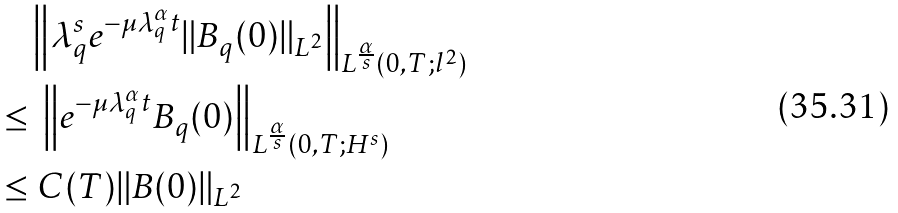Convert formula to latex. <formula><loc_0><loc_0><loc_500><loc_500>& \left \| \lambda _ { q } ^ { s } e ^ { - \mu \lambda _ { q } ^ { \alpha } t } \| B _ { q } ( 0 ) \| _ { L ^ { 2 } } \right \| _ { L ^ { \frac { \alpha } { s } } ( 0 , T ; l ^ { 2 } ) } \\ \leq & \ \left \| e ^ { - \mu \lambda _ { q } ^ { \alpha } t } B _ { q } ( 0 ) \right \| _ { L ^ { \frac { \alpha } { s } } ( 0 , T ; H ^ { s } ) } \\ \leq & \ C ( T ) \| B ( 0 ) \| _ { L ^ { 2 } }</formula> 